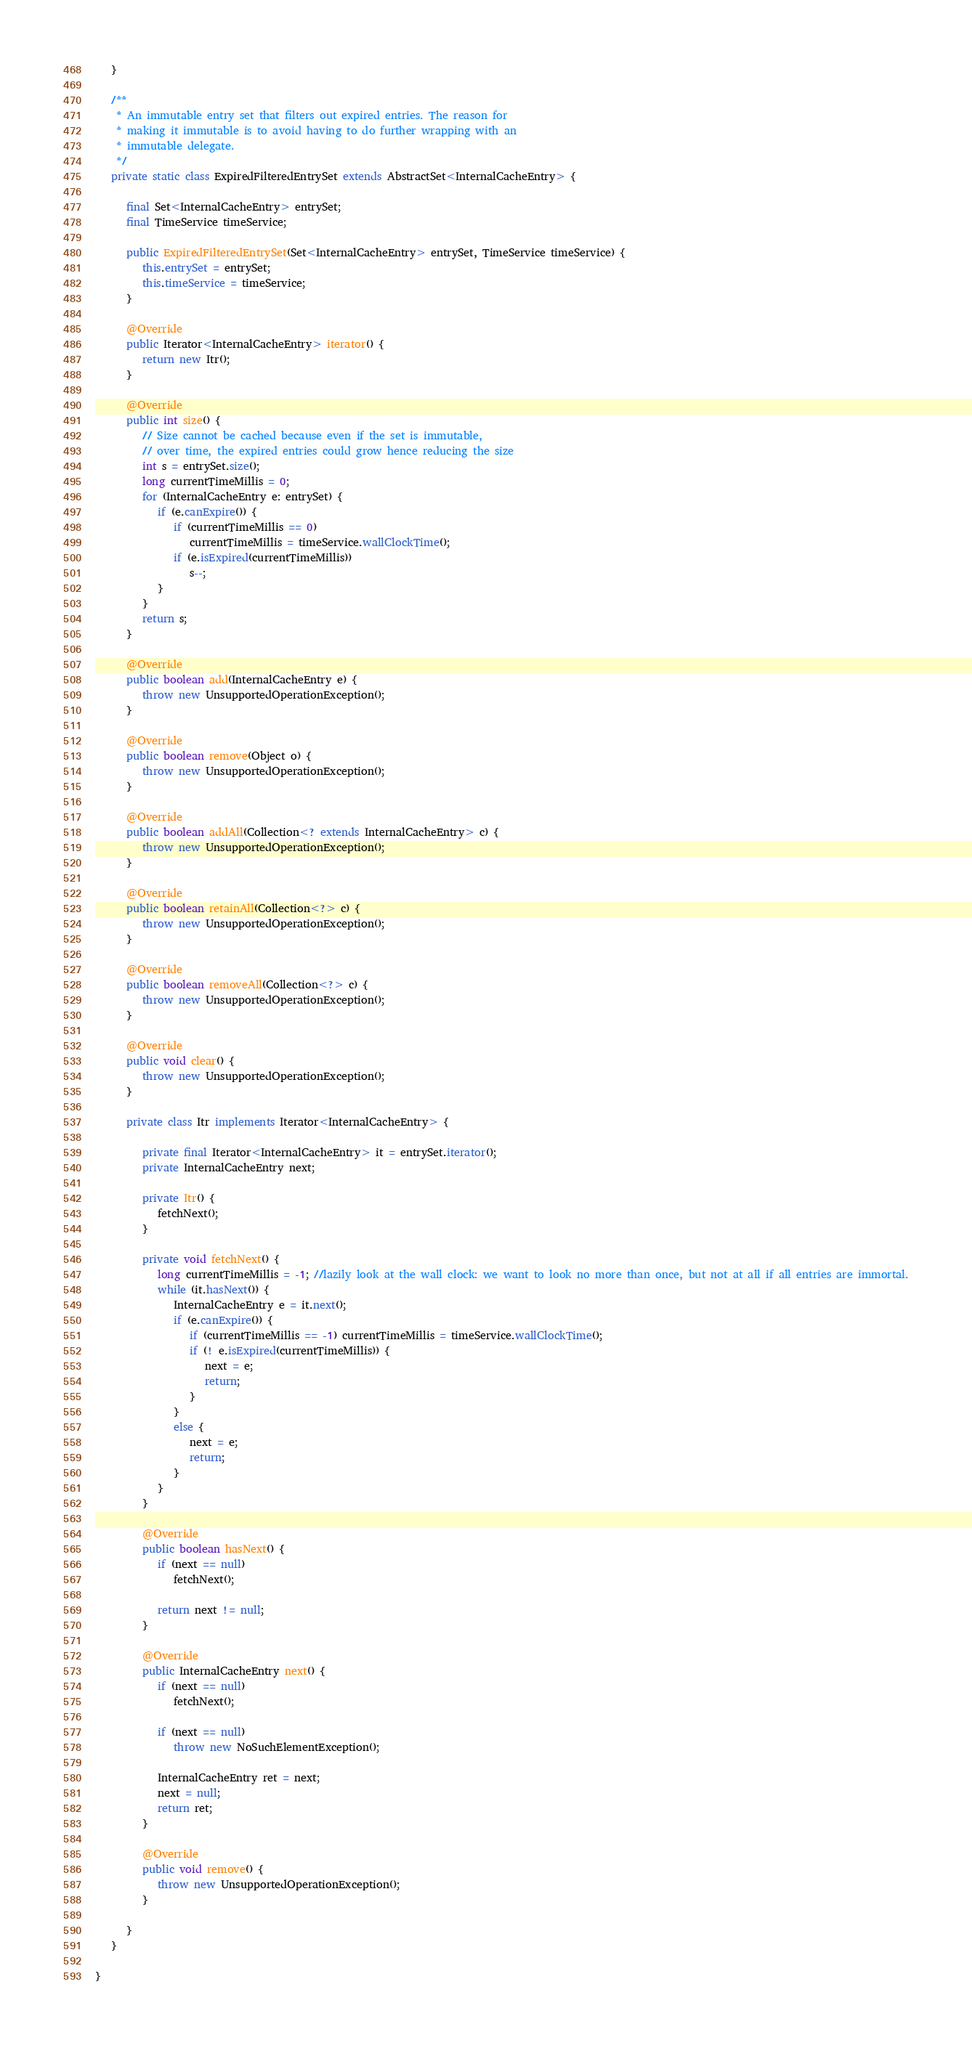Convert code to text. <code><loc_0><loc_0><loc_500><loc_500><_Java_>   }

   /**
    * An immutable entry set that filters out expired entries. The reason for
    * making it immutable is to avoid having to do further wrapping with an
    * immutable delegate.
    */
   private static class ExpiredFilteredEntrySet extends AbstractSet<InternalCacheEntry> {

      final Set<InternalCacheEntry> entrySet;
      final TimeService timeService;

      public ExpiredFilteredEntrySet(Set<InternalCacheEntry> entrySet, TimeService timeService) {
         this.entrySet = entrySet;
         this.timeService = timeService;
      }

      @Override
      public Iterator<InternalCacheEntry> iterator() {
         return new Itr();
      }

      @Override
      public int size() {
         // Size cannot be cached because even if the set is immutable,
         // over time, the expired entries could grow hence reducing the size
         int s = entrySet.size();
         long currentTimeMillis = 0;
         for (InternalCacheEntry e: entrySet) {
            if (e.canExpire()) {
               if (currentTimeMillis == 0)
                  currentTimeMillis = timeService.wallClockTime();
               if (e.isExpired(currentTimeMillis))
                  s--;
            }
         }
         return s;
      }

      @Override
      public boolean add(InternalCacheEntry e) {
         throw new UnsupportedOperationException();
      }

      @Override
      public boolean remove(Object o) {
         throw new UnsupportedOperationException();
      }

      @Override
      public boolean addAll(Collection<? extends InternalCacheEntry> c) {
         throw new UnsupportedOperationException();
      }

      @Override
      public boolean retainAll(Collection<?> c) {
         throw new UnsupportedOperationException();
      }

      @Override
      public boolean removeAll(Collection<?> c) {
         throw new UnsupportedOperationException();
      }

      @Override
      public void clear() {
         throw new UnsupportedOperationException();
      }

      private class Itr implements Iterator<InternalCacheEntry> {

         private final Iterator<InternalCacheEntry> it = entrySet.iterator();
         private InternalCacheEntry next;

         private Itr() {
            fetchNext();
         }

         private void fetchNext() {
            long currentTimeMillis = -1; //lazily look at the wall clock: we want to look no more than once, but not at all if all entries are immortal.
            while (it.hasNext()) {
               InternalCacheEntry e = it.next();
               if (e.canExpire()) {
                  if (currentTimeMillis == -1) currentTimeMillis = timeService.wallClockTime();
                  if (! e.isExpired(currentTimeMillis)) {
                     next = e;
                     return;
                  }
               }
               else {
                  next = e;
                  return;
               }
            }
         }

         @Override
         public boolean hasNext() {
            if (next == null)
               fetchNext();

            return next != null;
         }

         @Override
         public InternalCacheEntry next() {
            if (next == null)
               fetchNext();

            if (next == null)
               throw new NoSuchElementException();

            InternalCacheEntry ret = next;
            next = null;
            return ret;
         }

         @Override
         public void remove() {
            throw new UnsupportedOperationException();
         }

      }
   }

}
</code> 